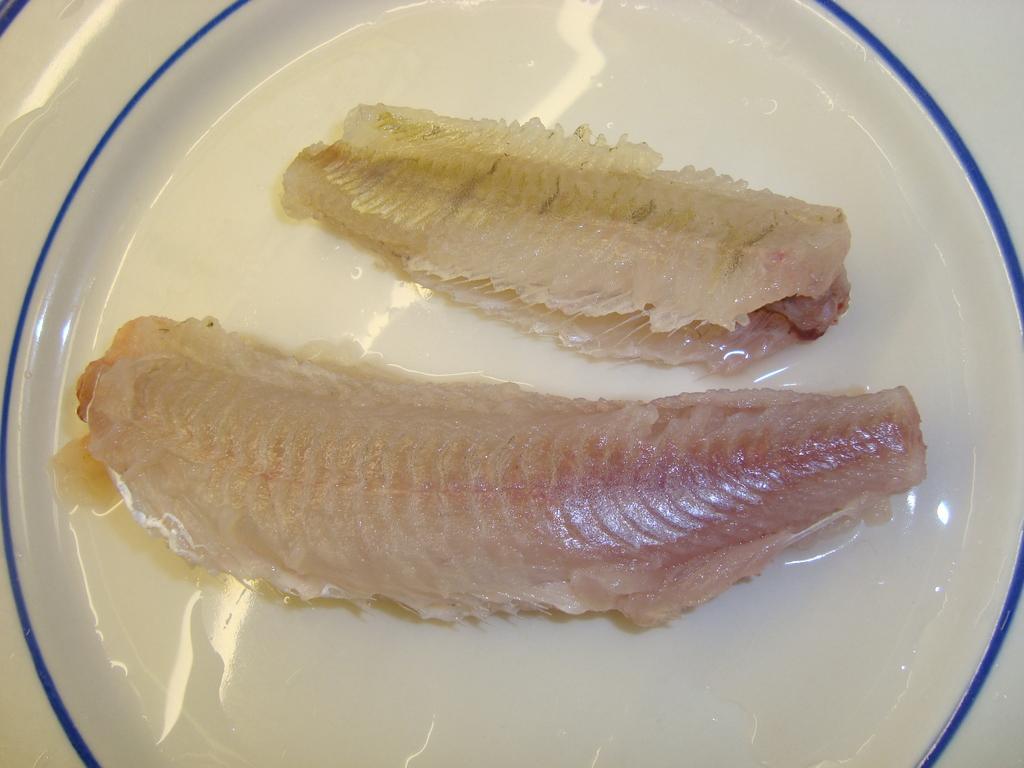Could you give a brief overview of what you see in this image? This image consists of a plate. It is in white color. On that there is some meat. 